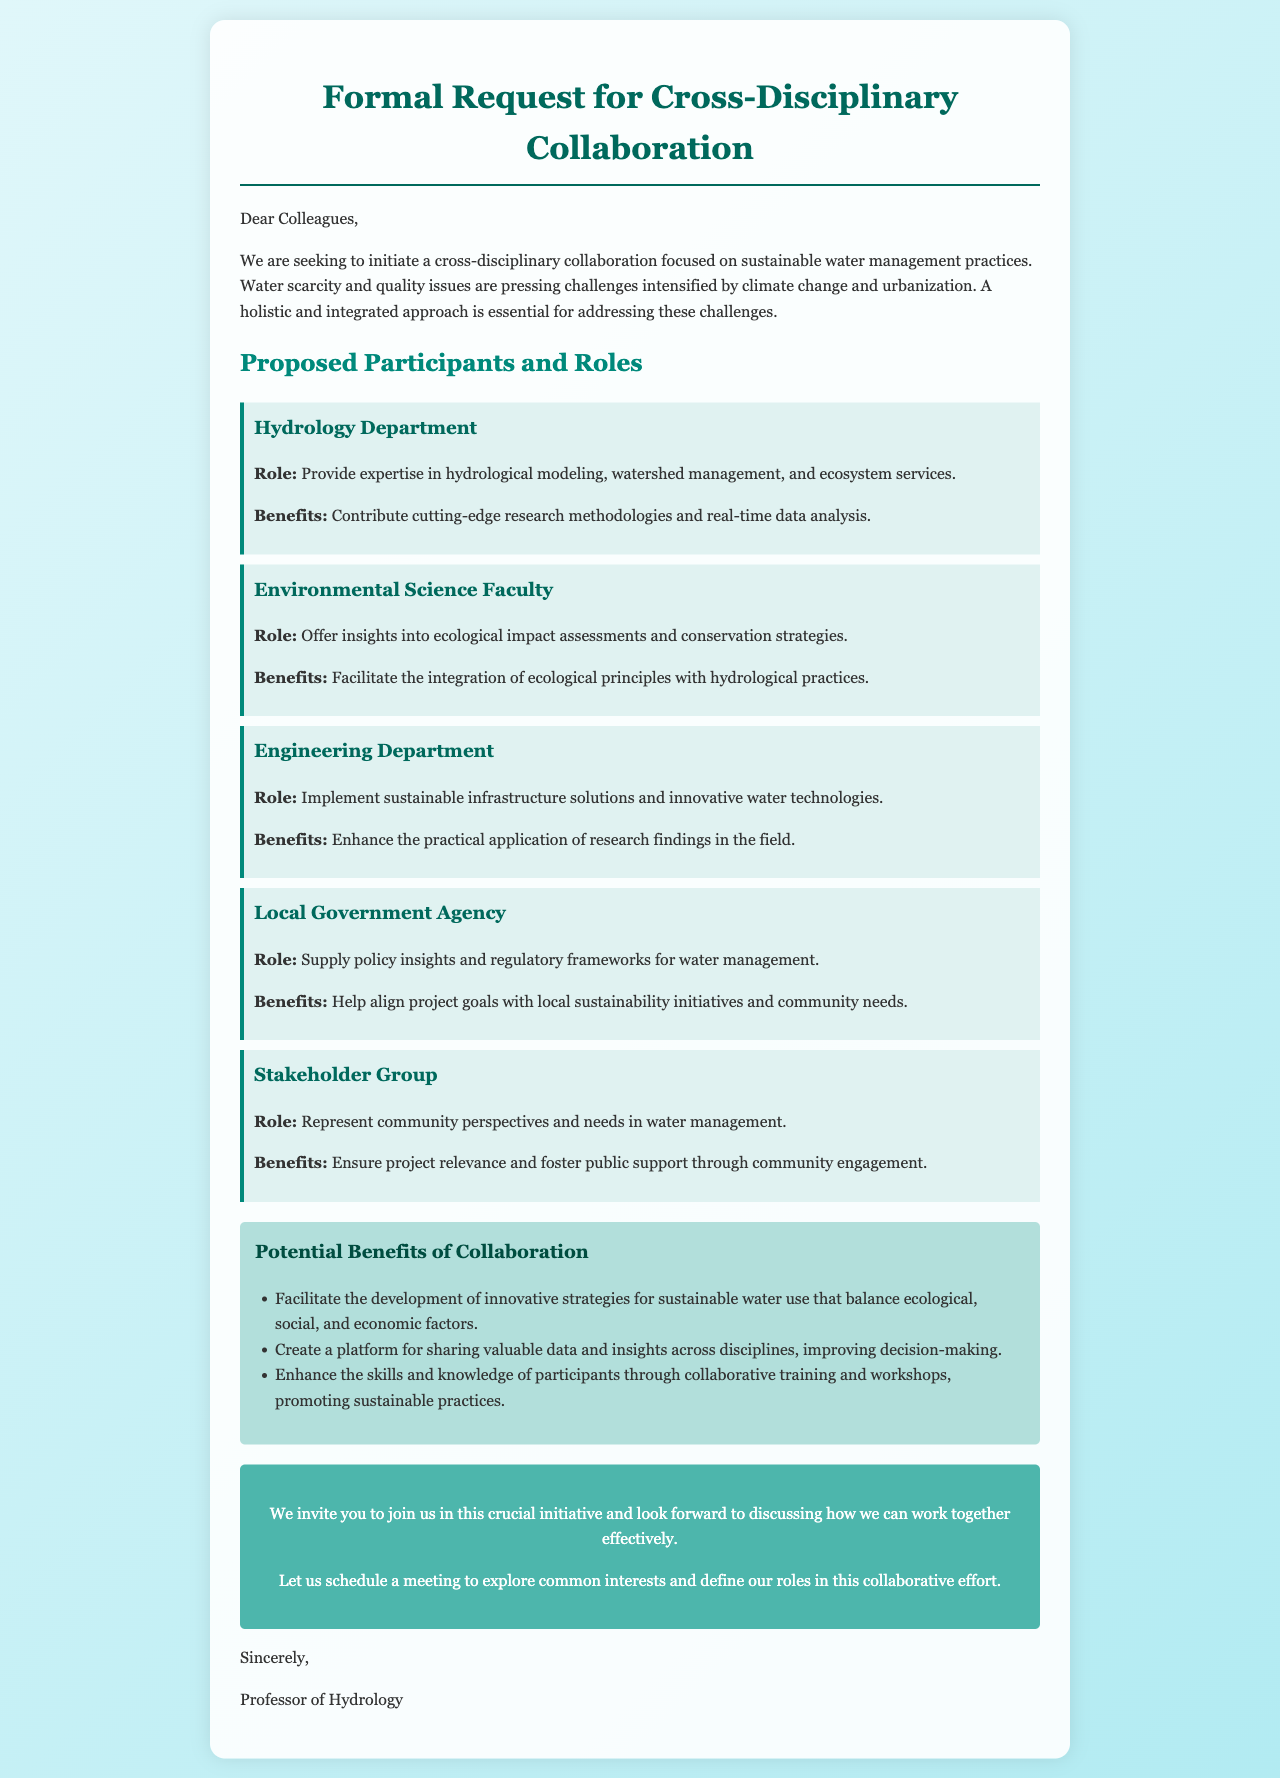What is the title of the document? The title appears at the top of the document, indicating the main subject of the letter.
Answer: Formal Request for Cross-Disciplinary Collaboration What is the main focus of the collaboration? The first paragraph outlines the primary objective of the collaboration mentioned in the letter.
Answer: Sustainable water management practices Who is the first proposed participant? The document lists participants in a specific order, starting with the first one mentioned.
Answer: Hydrology Department What role does the Engineering Department play? Each participant's role is detailed in a specific section, highlighting their responsibilities.
Answer: Implement sustainable infrastructure solutions and innovative water technologies What is one benefit of the Hydrology Department's involvement? The benefits of each participant's involvement are outlined, specifically mentioning contributions made.
Answer: Contribute cutting-edge research methodologies and real-time data analysis How many potential benefits of collaboration are listed? The number of benefits can be determined by counting the items in the provided list.
Answer: Three What does the Local Government Agency provide? This is specified in the section detailing each participant's roles and contributions in the collaboration.
Answer: Policy insights and regulatory frameworks for water management What is the concluding request in the letter? The final paragraphs summarize the invitation and suggest an action to initiate collaboration.
Answer: Schedule a meeting to explore common interests and define our roles What is the document's primary challenge related to? The document identifies two major issues at the beginning that the collaboration aims to address.
Answer: Water scarcity and quality issues 